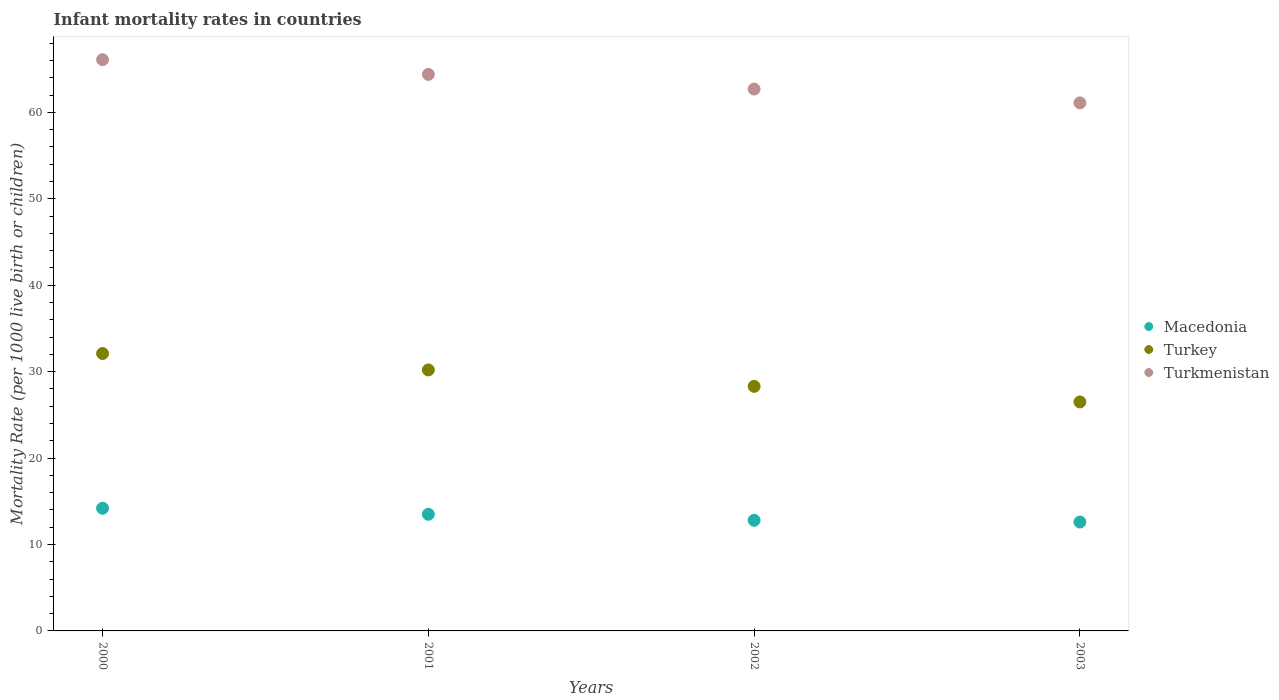Is the number of dotlines equal to the number of legend labels?
Offer a very short reply. Yes. Across all years, what is the minimum infant mortality rate in Macedonia?
Offer a very short reply. 12.6. What is the total infant mortality rate in Turkmenistan in the graph?
Offer a very short reply. 254.3. What is the difference between the infant mortality rate in Macedonia in 2001 and that in 2003?
Ensure brevity in your answer.  0.9. What is the difference between the infant mortality rate in Macedonia in 2003 and the infant mortality rate in Turkey in 2001?
Offer a very short reply. -17.6. What is the average infant mortality rate in Turkey per year?
Provide a succinct answer. 29.27. In the year 2000, what is the difference between the infant mortality rate in Macedonia and infant mortality rate in Turkmenistan?
Your response must be concise. -51.9. In how many years, is the infant mortality rate in Turkey greater than 42?
Give a very brief answer. 0. What is the ratio of the infant mortality rate in Turkmenistan in 2000 to that in 2003?
Provide a short and direct response. 1.08. Is the infant mortality rate in Turkey in 2002 less than that in 2003?
Ensure brevity in your answer.  No. What is the difference between the highest and the second highest infant mortality rate in Macedonia?
Your answer should be compact. 0.7. What is the difference between the highest and the lowest infant mortality rate in Macedonia?
Your answer should be compact. 1.6. In how many years, is the infant mortality rate in Turkmenistan greater than the average infant mortality rate in Turkmenistan taken over all years?
Give a very brief answer. 2. Is the sum of the infant mortality rate in Macedonia in 2000 and 2002 greater than the maximum infant mortality rate in Turkey across all years?
Offer a terse response. No. Is the infant mortality rate in Macedonia strictly greater than the infant mortality rate in Turkey over the years?
Ensure brevity in your answer.  No. How many dotlines are there?
Offer a terse response. 3. How many years are there in the graph?
Your response must be concise. 4. What is the difference between two consecutive major ticks on the Y-axis?
Offer a terse response. 10. Are the values on the major ticks of Y-axis written in scientific E-notation?
Provide a succinct answer. No. Does the graph contain any zero values?
Your answer should be very brief. No. Does the graph contain grids?
Offer a very short reply. No. Where does the legend appear in the graph?
Your response must be concise. Center right. What is the title of the graph?
Make the answer very short. Infant mortality rates in countries. What is the label or title of the Y-axis?
Ensure brevity in your answer.  Mortality Rate (per 1000 live birth or children). What is the Mortality Rate (per 1000 live birth or children) of Turkey in 2000?
Ensure brevity in your answer.  32.1. What is the Mortality Rate (per 1000 live birth or children) of Turkmenistan in 2000?
Provide a succinct answer. 66.1. What is the Mortality Rate (per 1000 live birth or children) of Macedonia in 2001?
Make the answer very short. 13.5. What is the Mortality Rate (per 1000 live birth or children) of Turkey in 2001?
Your answer should be compact. 30.2. What is the Mortality Rate (per 1000 live birth or children) in Turkmenistan in 2001?
Offer a very short reply. 64.4. What is the Mortality Rate (per 1000 live birth or children) in Turkey in 2002?
Ensure brevity in your answer.  28.3. What is the Mortality Rate (per 1000 live birth or children) in Turkmenistan in 2002?
Provide a succinct answer. 62.7. What is the Mortality Rate (per 1000 live birth or children) of Macedonia in 2003?
Ensure brevity in your answer.  12.6. What is the Mortality Rate (per 1000 live birth or children) of Turkmenistan in 2003?
Your answer should be very brief. 61.1. Across all years, what is the maximum Mortality Rate (per 1000 live birth or children) of Macedonia?
Ensure brevity in your answer.  14.2. Across all years, what is the maximum Mortality Rate (per 1000 live birth or children) of Turkey?
Make the answer very short. 32.1. Across all years, what is the maximum Mortality Rate (per 1000 live birth or children) in Turkmenistan?
Provide a succinct answer. 66.1. Across all years, what is the minimum Mortality Rate (per 1000 live birth or children) of Turkey?
Offer a very short reply. 26.5. Across all years, what is the minimum Mortality Rate (per 1000 live birth or children) in Turkmenistan?
Offer a very short reply. 61.1. What is the total Mortality Rate (per 1000 live birth or children) of Macedonia in the graph?
Your answer should be compact. 53.1. What is the total Mortality Rate (per 1000 live birth or children) of Turkey in the graph?
Ensure brevity in your answer.  117.1. What is the total Mortality Rate (per 1000 live birth or children) of Turkmenistan in the graph?
Your response must be concise. 254.3. What is the difference between the Mortality Rate (per 1000 live birth or children) in Macedonia in 2000 and that in 2001?
Your answer should be very brief. 0.7. What is the difference between the Mortality Rate (per 1000 live birth or children) in Turkey in 2000 and that in 2001?
Offer a terse response. 1.9. What is the difference between the Mortality Rate (per 1000 live birth or children) in Macedonia in 2000 and that in 2002?
Offer a very short reply. 1.4. What is the difference between the Mortality Rate (per 1000 live birth or children) of Turkey in 2000 and that in 2003?
Your answer should be very brief. 5.6. What is the difference between the Mortality Rate (per 1000 live birth or children) in Turkmenistan in 2000 and that in 2003?
Give a very brief answer. 5. What is the difference between the Mortality Rate (per 1000 live birth or children) in Macedonia in 2001 and that in 2002?
Keep it short and to the point. 0.7. What is the difference between the Mortality Rate (per 1000 live birth or children) in Macedonia in 2001 and that in 2003?
Keep it short and to the point. 0.9. What is the difference between the Mortality Rate (per 1000 live birth or children) in Turkey in 2001 and that in 2003?
Provide a short and direct response. 3.7. What is the difference between the Mortality Rate (per 1000 live birth or children) in Turkmenistan in 2001 and that in 2003?
Ensure brevity in your answer.  3.3. What is the difference between the Mortality Rate (per 1000 live birth or children) in Macedonia in 2002 and that in 2003?
Make the answer very short. 0.2. What is the difference between the Mortality Rate (per 1000 live birth or children) in Turkey in 2002 and that in 2003?
Keep it short and to the point. 1.8. What is the difference between the Mortality Rate (per 1000 live birth or children) of Turkmenistan in 2002 and that in 2003?
Offer a very short reply. 1.6. What is the difference between the Mortality Rate (per 1000 live birth or children) in Macedonia in 2000 and the Mortality Rate (per 1000 live birth or children) in Turkmenistan in 2001?
Your response must be concise. -50.2. What is the difference between the Mortality Rate (per 1000 live birth or children) of Turkey in 2000 and the Mortality Rate (per 1000 live birth or children) of Turkmenistan in 2001?
Give a very brief answer. -32.3. What is the difference between the Mortality Rate (per 1000 live birth or children) in Macedonia in 2000 and the Mortality Rate (per 1000 live birth or children) in Turkey in 2002?
Make the answer very short. -14.1. What is the difference between the Mortality Rate (per 1000 live birth or children) in Macedonia in 2000 and the Mortality Rate (per 1000 live birth or children) in Turkmenistan in 2002?
Offer a terse response. -48.5. What is the difference between the Mortality Rate (per 1000 live birth or children) of Turkey in 2000 and the Mortality Rate (per 1000 live birth or children) of Turkmenistan in 2002?
Your answer should be very brief. -30.6. What is the difference between the Mortality Rate (per 1000 live birth or children) of Macedonia in 2000 and the Mortality Rate (per 1000 live birth or children) of Turkey in 2003?
Ensure brevity in your answer.  -12.3. What is the difference between the Mortality Rate (per 1000 live birth or children) of Macedonia in 2000 and the Mortality Rate (per 1000 live birth or children) of Turkmenistan in 2003?
Your response must be concise. -46.9. What is the difference between the Mortality Rate (per 1000 live birth or children) in Macedonia in 2001 and the Mortality Rate (per 1000 live birth or children) in Turkey in 2002?
Give a very brief answer. -14.8. What is the difference between the Mortality Rate (per 1000 live birth or children) in Macedonia in 2001 and the Mortality Rate (per 1000 live birth or children) in Turkmenistan in 2002?
Your response must be concise. -49.2. What is the difference between the Mortality Rate (per 1000 live birth or children) in Turkey in 2001 and the Mortality Rate (per 1000 live birth or children) in Turkmenistan in 2002?
Give a very brief answer. -32.5. What is the difference between the Mortality Rate (per 1000 live birth or children) of Macedonia in 2001 and the Mortality Rate (per 1000 live birth or children) of Turkey in 2003?
Offer a very short reply. -13. What is the difference between the Mortality Rate (per 1000 live birth or children) of Macedonia in 2001 and the Mortality Rate (per 1000 live birth or children) of Turkmenistan in 2003?
Give a very brief answer. -47.6. What is the difference between the Mortality Rate (per 1000 live birth or children) of Turkey in 2001 and the Mortality Rate (per 1000 live birth or children) of Turkmenistan in 2003?
Your answer should be very brief. -30.9. What is the difference between the Mortality Rate (per 1000 live birth or children) of Macedonia in 2002 and the Mortality Rate (per 1000 live birth or children) of Turkey in 2003?
Provide a succinct answer. -13.7. What is the difference between the Mortality Rate (per 1000 live birth or children) in Macedonia in 2002 and the Mortality Rate (per 1000 live birth or children) in Turkmenistan in 2003?
Offer a terse response. -48.3. What is the difference between the Mortality Rate (per 1000 live birth or children) of Turkey in 2002 and the Mortality Rate (per 1000 live birth or children) of Turkmenistan in 2003?
Provide a short and direct response. -32.8. What is the average Mortality Rate (per 1000 live birth or children) of Macedonia per year?
Provide a succinct answer. 13.28. What is the average Mortality Rate (per 1000 live birth or children) in Turkey per year?
Your answer should be compact. 29.27. What is the average Mortality Rate (per 1000 live birth or children) in Turkmenistan per year?
Provide a short and direct response. 63.58. In the year 2000, what is the difference between the Mortality Rate (per 1000 live birth or children) in Macedonia and Mortality Rate (per 1000 live birth or children) in Turkey?
Give a very brief answer. -17.9. In the year 2000, what is the difference between the Mortality Rate (per 1000 live birth or children) of Macedonia and Mortality Rate (per 1000 live birth or children) of Turkmenistan?
Offer a very short reply. -51.9. In the year 2000, what is the difference between the Mortality Rate (per 1000 live birth or children) of Turkey and Mortality Rate (per 1000 live birth or children) of Turkmenistan?
Your answer should be compact. -34. In the year 2001, what is the difference between the Mortality Rate (per 1000 live birth or children) in Macedonia and Mortality Rate (per 1000 live birth or children) in Turkey?
Make the answer very short. -16.7. In the year 2001, what is the difference between the Mortality Rate (per 1000 live birth or children) of Macedonia and Mortality Rate (per 1000 live birth or children) of Turkmenistan?
Your answer should be compact. -50.9. In the year 2001, what is the difference between the Mortality Rate (per 1000 live birth or children) of Turkey and Mortality Rate (per 1000 live birth or children) of Turkmenistan?
Your answer should be compact. -34.2. In the year 2002, what is the difference between the Mortality Rate (per 1000 live birth or children) of Macedonia and Mortality Rate (per 1000 live birth or children) of Turkey?
Offer a terse response. -15.5. In the year 2002, what is the difference between the Mortality Rate (per 1000 live birth or children) in Macedonia and Mortality Rate (per 1000 live birth or children) in Turkmenistan?
Make the answer very short. -49.9. In the year 2002, what is the difference between the Mortality Rate (per 1000 live birth or children) in Turkey and Mortality Rate (per 1000 live birth or children) in Turkmenistan?
Your answer should be very brief. -34.4. In the year 2003, what is the difference between the Mortality Rate (per 1000 live birth or children) of Macedonia and Mortality Rate (per 1000 live birth or children) of Turkmenistan?
Give a very brief answer. -48.5. In the year 2003, what is the difference between the Mortality Rate (per 1000 live birth or children) of Turkey and Mortality Rate (per 1000 live birth or children) of Turkmenistan?
Offer a very short reply. -34.6. What is the ratio of the Mortality Rate (per 1000 live birth or children) of Macedonia in 2000 to that in 2001?
Make the answer very short. 1.05. What is the ratio of the Mortality Rate (per 1000 live birth or children) in Turkey in 2000 to that in 2001?
Provide a succinct answer. 1.06. What is the ratio of the Mortality Rate (per 1000 live birth or children) of Turkmenistan in 2000 to that in 2001?
Make the answer very short. 1.03. What is the ratio of the Mortality Rate (per 1000 live birth or children) in Macedonia in 2000 to that in 2002?
Keep it short and to the point. 1.11. What is the ratio of the Mortality Rate (per 1000 live birth or children) of Turkey in 2000 to that in 2002?
Offer a terse response. 1.13. What is the ratio of the Mortality Rate (per 1000 live birth or children) of Turkmenistan in 2000 to that in 2002?
Offer a terse response. 1.05. What is the ratio of the Mortality Rate (per 1000 live birth or children) in Macedonia in 2000 to that in 2003?
Keep it short and to the point. 1.13. What is the ratio of the Mortality Rate (per 1000 live birth or children) of Turkey in 2000 to that in 2003?
Provide a succinct answer. 1.21. What is the ratio of the Mortality Rate (per 1000 live birth or children) of Turkmenistan in 2000 to that in 2003?
Offer a terse response. 1.08. What is the ratio of the Mortality Rate (per 1000 live birth or children) in Macedonia in 2001 to that in 2002?
Ensure brevity in your answer.  1.05. What is the ratio of the Mortality Rate (per 1000 live birth or children) of Turkey in 2001 to that in 2002?
Keep it short and to the point. 1.07. What is the ratio of the Mortality Rate (per 1000 live birth or children) in Turkmenistan in 2001 to that in 2002?
Your answer should be compact. 1.03. What is the ratio of the Mortality Rate (per 1000 live birth or children) of Macedonia in 2001 to that in 2003?
Provide a short and direct response. 1.07. What is the ratio of the Mortality Rate (per 1000 live birth or children) in Turkey in 2001 to that in 2003?
Give a very brief answer. 1.14. What is the ratio of the Mortality Rate (per 1000 live birth or children) in Turkmenistan in 2001 to that in 2003?
Provide a short and direct response. 1.05. What is the ratio of the Mortality Rate (per 1000 live birth or children) of Macedonia in 2002 to that in 2003?
Provide a short and direct response. 1.02. What is the ratio of the Mortality Rate (per 1000 live birth or children) in Turkey in 2002 to that in 2003?
Give a very brief answer. 1.07. What is the ratio of the Mortality Rate (per 1000 live birth or children) of Turkmenistan in 2002 to that in 2003?
Keep it short and to the point. 1.03. What is the difference between the highest and the second highest Mortality Rate (per 1000 live birth or children) of Macedonia?
Keep it short and to the point. 0.7. What is the difference between the highest and the second highest Mortality Rate (per 1000 live birth or children) in Turkey?
Keep it short and to the point. 1.9. What is the difference between the highest and the second highest Mortality Rate (per 1000 live birth or children) of Turkmenistan?
Your answer should be very brief. 1.7. What is the difference between the highest and the lowest Mortality Rate (per 1000 live birth or children) in Turkey?
Your response must be concise. 5.6. What is the difference between the highest and the lowest Mortality Rate (per 1000 live birth or children) in Turkmenistan?
Ensure brevity in your answer.  5. 